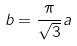Convert formula to latex. <formula><loc_0><loc_0><loc_500><loc_500>b = \frac { \pi } { \sqrt { 3 } } a</formula> 